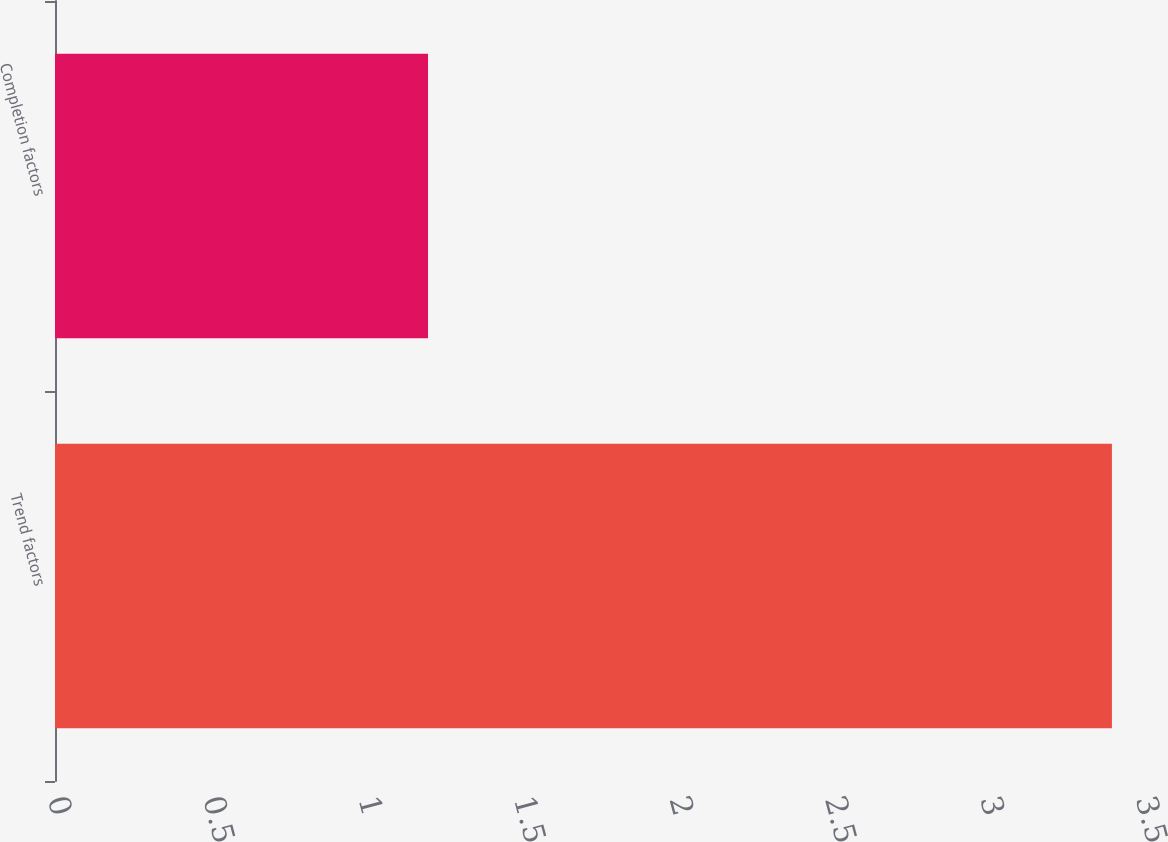<chart> <loc_0><loc_0><loc_500><loc_500><bar_chart><fcel>Trend factors<fcel>Completion factors<nl><fcel>3.4<fcel>1.2<nl></chart> 